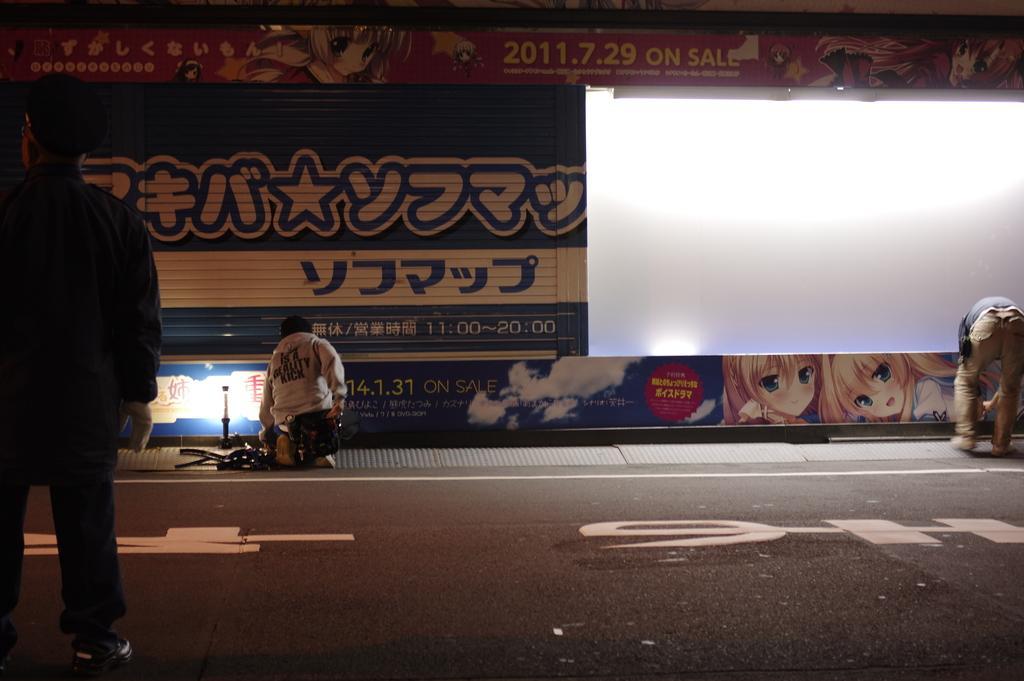In one or two sentences, can you explain what this image depicts? In this image there is a person standing, in front of him there are two other people on the pavement with some objects behind them, in front of them there are metal shutters of a shop, above the shutters there is display board. 